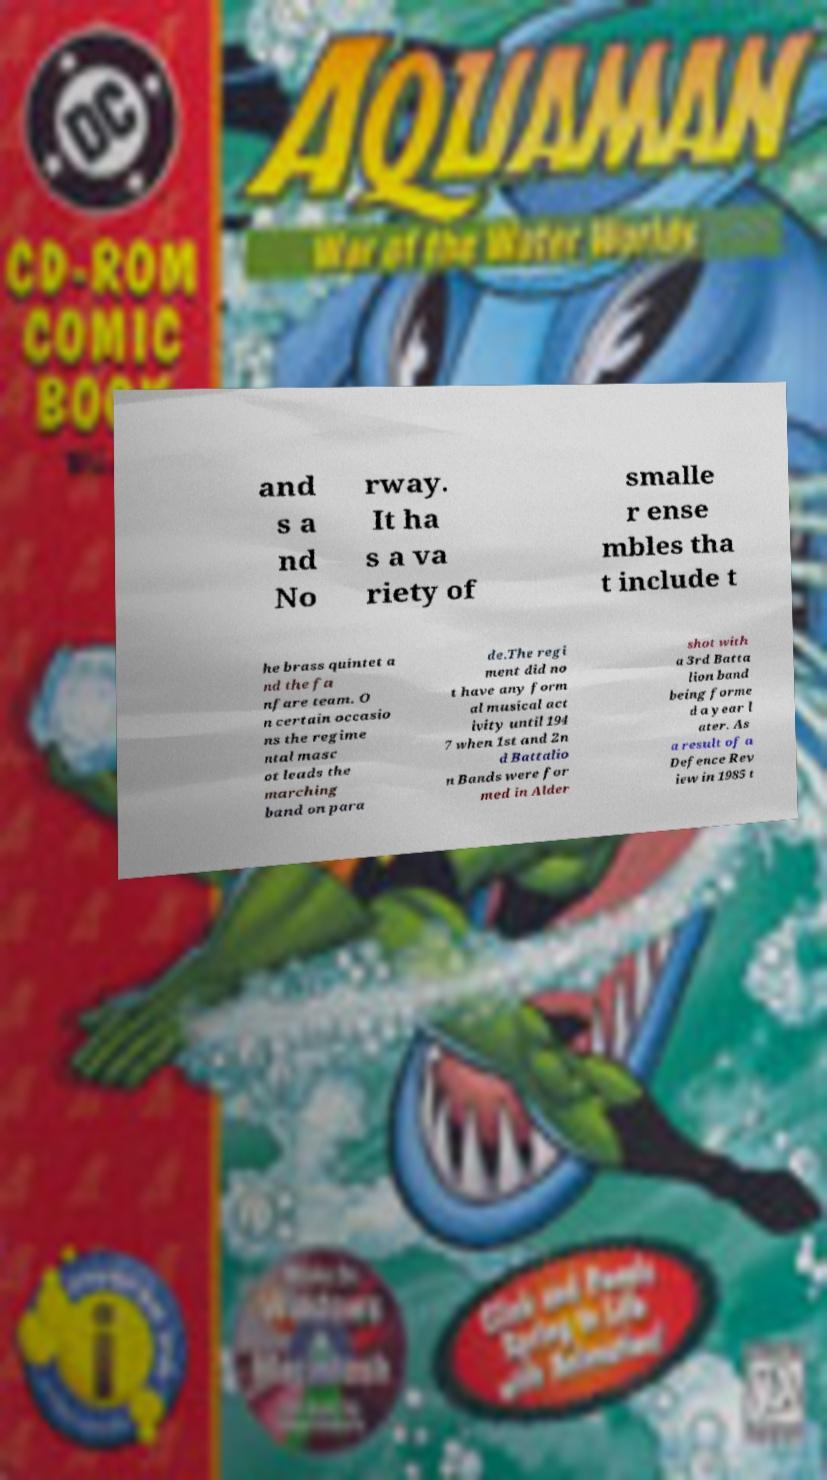What messages or text are displayed in this image? I need them in a readable, typed format. and s a nd No rway. It ha s a va riety of smalle r ense mbles tha t include t he brass quintet a nd the fa nfare team. O n certain occasio ns the regime ntal masc ot leads the marching band on para de.The regi ment did no t have any form al musical act ivity until 194 7 when 1st and 2n d Battalio n Bands were for med in Alder shot with a 3rd Batta lion band being forme d a year l ater. As a result of a Defence Rev iew in 1985 t 